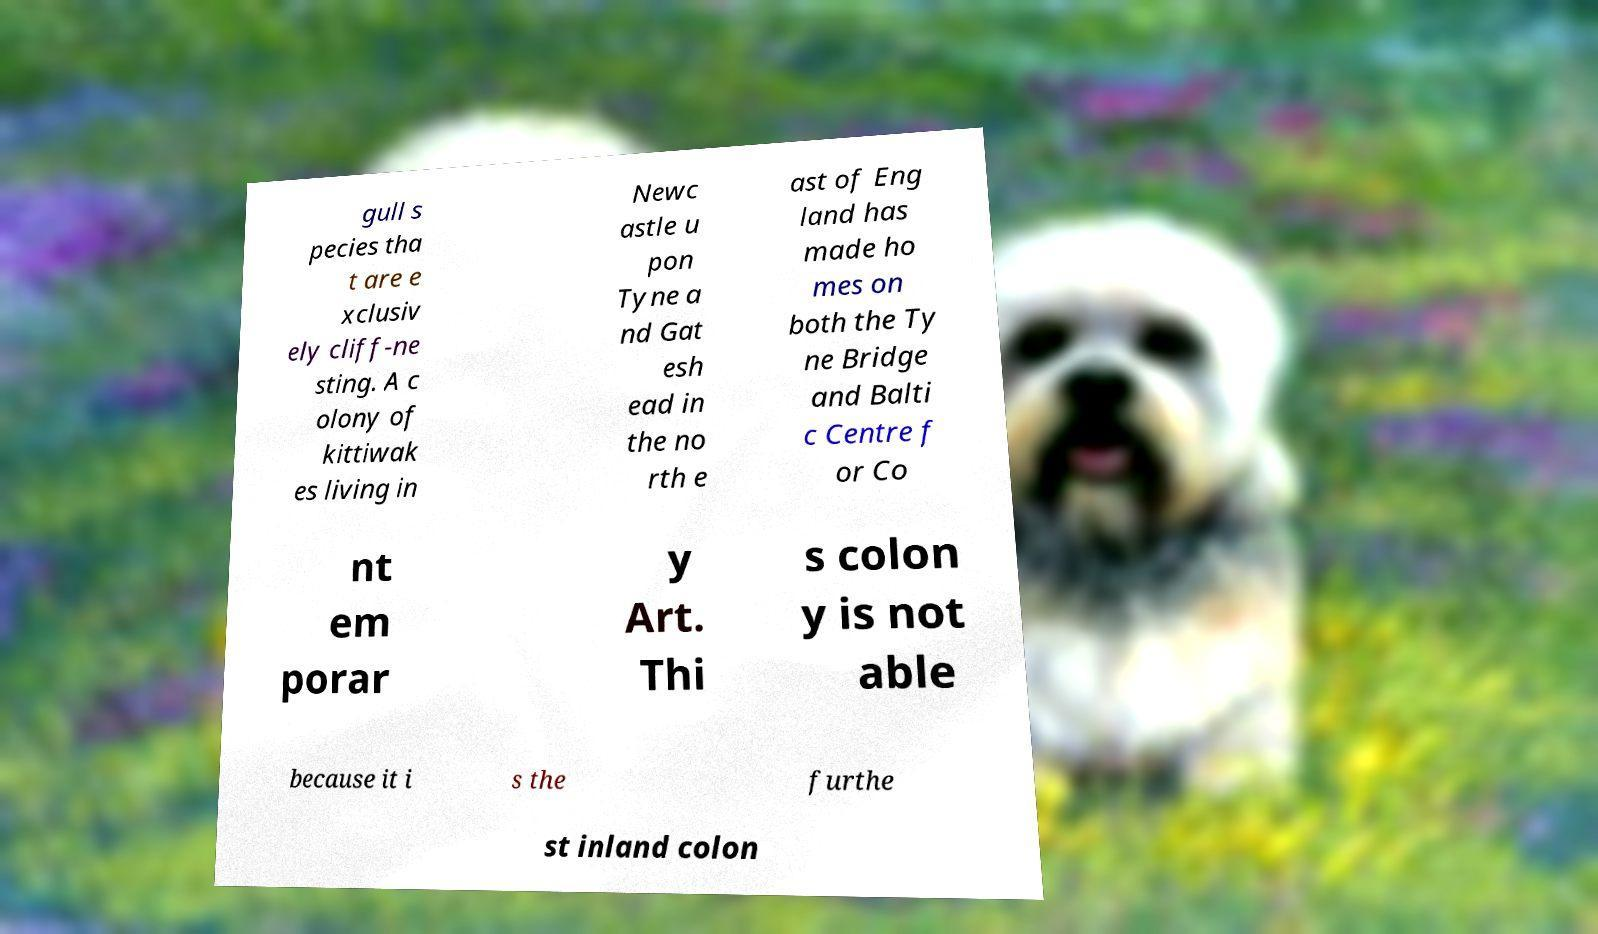Could you extract and type out the text from this image? gull s pecies tha t are e xclusiv ely cliff-ne sting. A c olony of kittiwak es living in Newc astle u pon Tyne a nd Gat esh ead in the no rth e ast of Eng land has made ho mes on both the Ty ne Bridge and Balti c Centre f or Co nt em porar y Art. Thi s colon y is not able because it i s the furthe st inland colon 